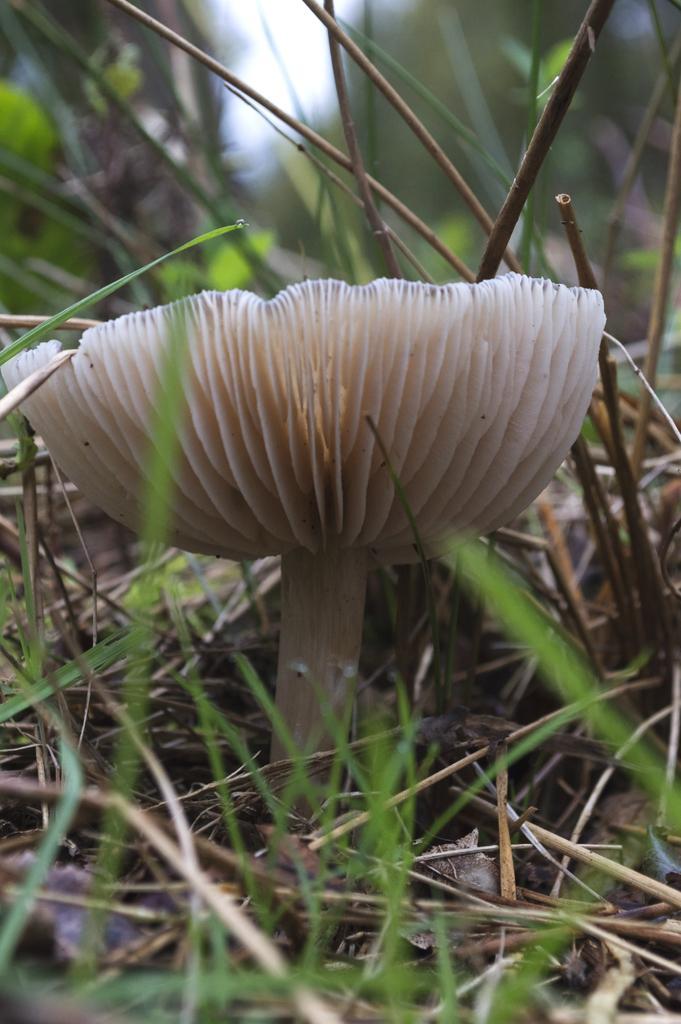Could you give a brief overview of what you see in this image? In this image we can see a mushroom, around the mushroom we can see the grass and the background is blurred. 